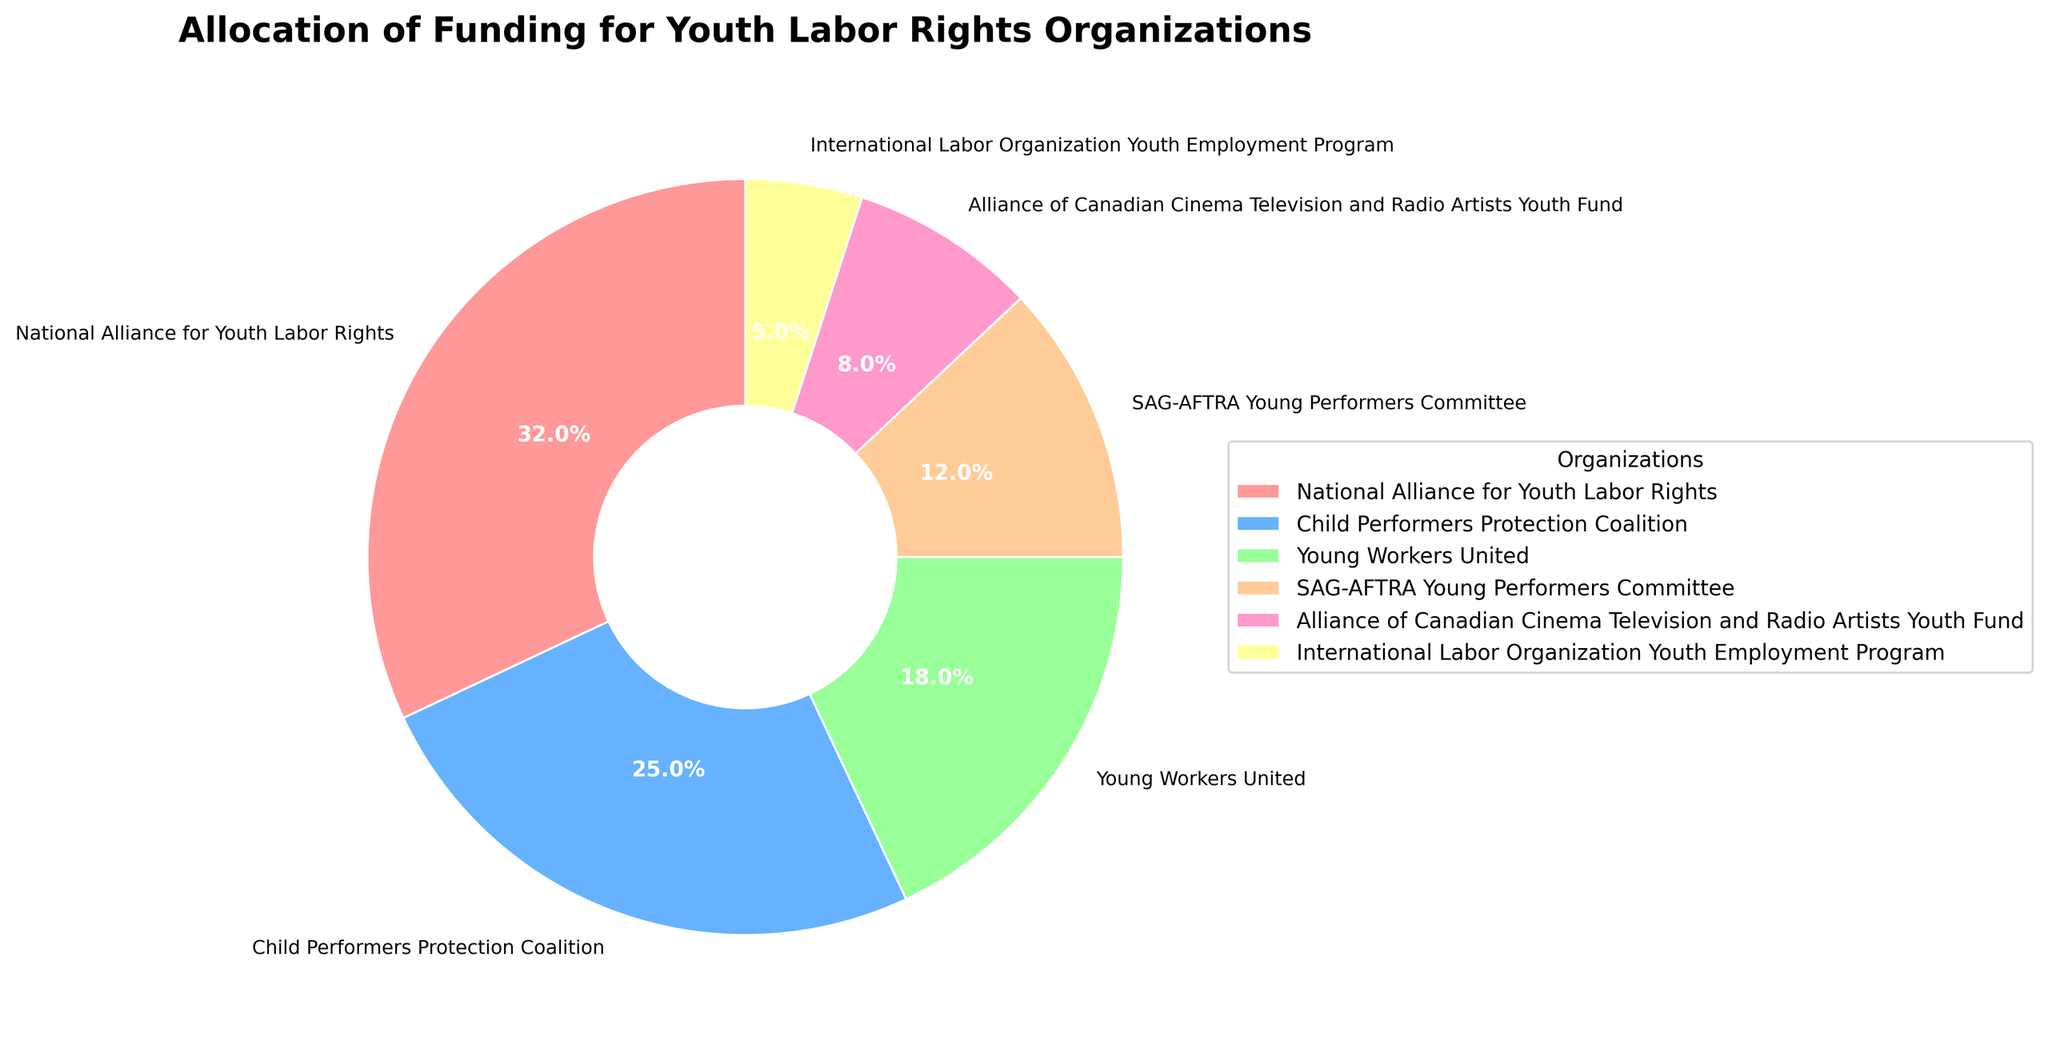Which organization receives the highest funding allocation? The pie chart shows the sizes of each organization's funding allocation as percentages. The largest percentage slice represents the National Alliance for Youth Labor Rights.
Answer: National Alliance for Youth Labor Rights Which organization receives the lowest funding allocation? The smallest slice on the pie chart denotes the organization with the lowest funding allocation, which is the International Labor Organization Youth Employment Program.
Answer: International Labor Organization Youth Employment Program What is the combined funding allocation percentage of the Child Performers Protection Coalition and the SAG-AFTRA Young Performers Committee? The pie chart indicates that the Child Performers Protection Coalition receives 25% of the funding and the SAG-AFTRA Young Performers Committee receives 12%. Summing these percentages gives 25% + 12% = 37%.
Answer: 37% By what percentage does the funding allocation of the National Alliance for Youth Labor Rights exceed Young Workers United? The pie chart shows that the National Alliance for Youth Labor Rights receives 32% of the funding, while Young Workers United receives 18%. The difference is 32% - 18% = 14%.
Answer: 14% Which organizations have a funding allocation between 10% and 20%? By examining the pie chart, we can see that Young Workers United has 18%, and the SAG-AFTRA Young Performers Committee has 12%. Both of these values fall between 10% and 20%.
Answer: Young Workers United and SAG-AFTRA Young Performers Committee How much more funding does the Child Performers Protection Coalition receive compared to the Alliance of Canadian Cinema Television, and Radio Artists Youth Fund? The pie chart shows that the Child Performers Protection Coalition has a 25% allocation and the Alliance of Canadian Cinema Television and Radio Artists Youth Fund has 8%. The difference is 25% - 8% = 17%.
Answer: 17% What is the average funding allocation for all organizations? The pie chart lists six organizations with funding allocations of 32%, 25%, 18%, 12%, 8%, and 5%. The average is calculated as \((32 + 25 + 18 + 12 + 8 + 5) / 6 = 100 / 6 = 16.67\%\).
Answer: 16.67% What is the funding allocation percentage difference between the highest-funded and lowest-funded organizations? The pie chart indicates that the National Alliance for Youth Labor Rights has the highest funding at 32%, and the International Labor Organization Youth Employment Program has the lowest at 5%. The difference is 32% - 5% = 27%.
Answer: 27% Which slice is represented by a pink color? In the pie chart, pink is used to designate the largest percentage. Therefore, the pink slice represents the National Alliance for Youth Labor Rights.
Answer: National Alliance for Youth Labor Rights 